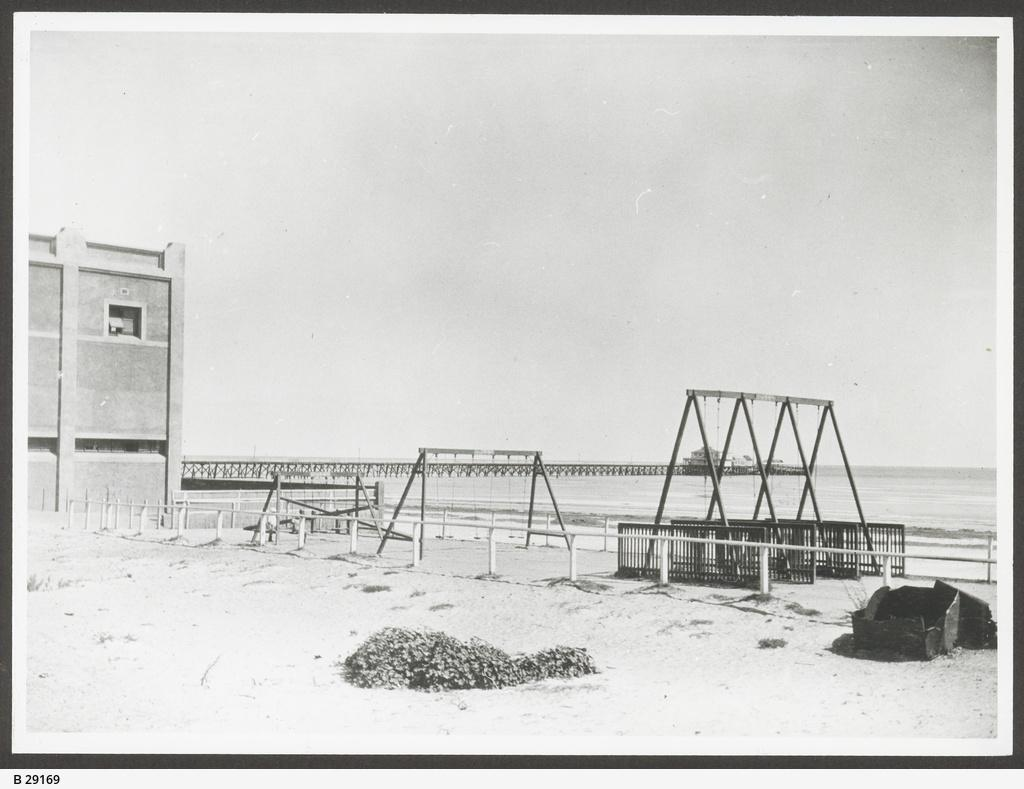What can be seen in rows in the image? There are rows with cradles in the image. What structure is located in the left corner of the image? There is a building in the left corner of the image. What is visible in the background of the image? There is water and a bridge visible in the background of the image. Can you see a trail of salt leading to the cradles in the image? There is no trail of salt present in the image. How many apples are hanging from the bridge in the background? There are no apples visible in the image, and the bridge is not depicted as having any hanging from it. 